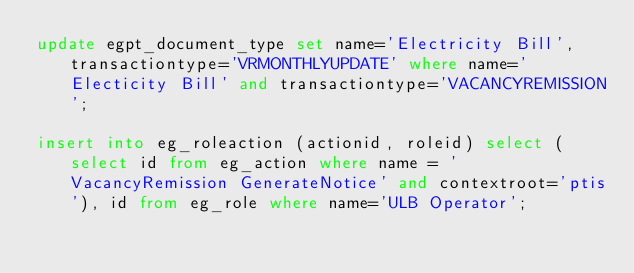<code> <loc_0><loc_0><loc_500><loc_500><_SQL_>update egpt_document_type set name='Electricity Bill',transactiontype='VRMONTHLYUPDATE' where name='Electicity Bill' and transactiontype='VACANCYREMISSION';

insert into eg_roleaction (actionid, roleid) select (select id from eg_action where name = 'VacancyRemission GenerateNotice' and contextroot='ptis'), id from eg_role where name='ULB Operator';

</code> 